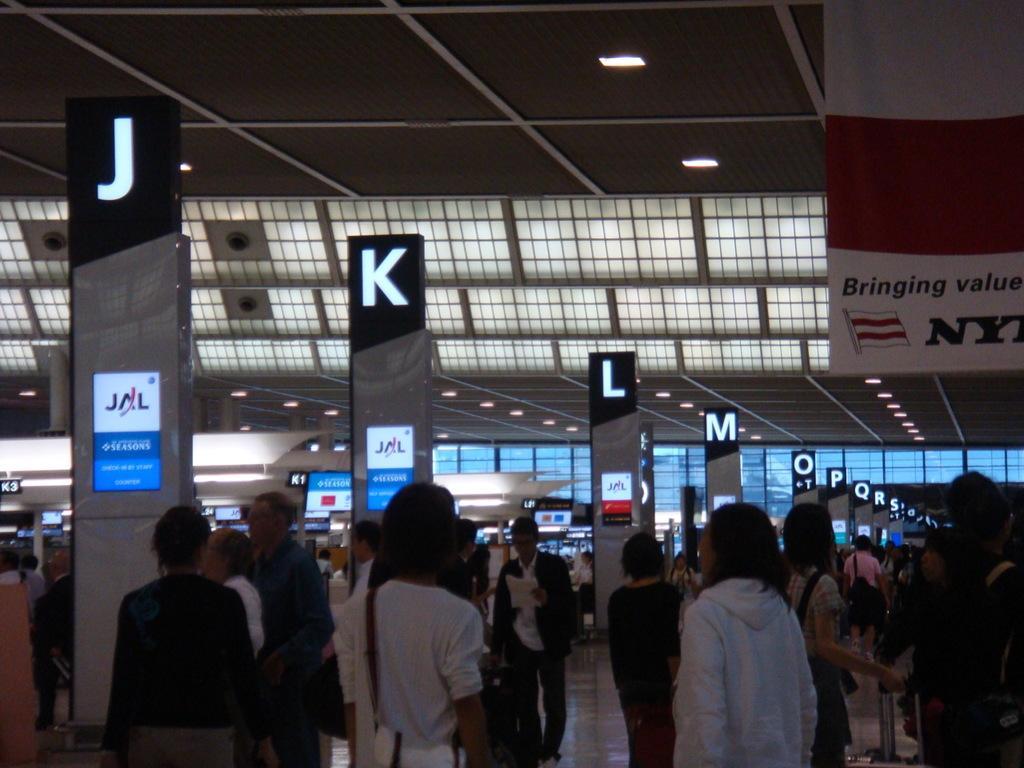Please provide a concise description of this image. In this image there are a few people standing and walking by holding luggage in their hands inside an airport and there are a few counters with screens on them, on top of the image there is a banner hanging from the ceiling. 